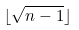Convert formula to latex. <formula><loc_0><loc_0><loc_500><loc_500>\lfloor \sqrt { n - 1 } \rfloor</formula> 